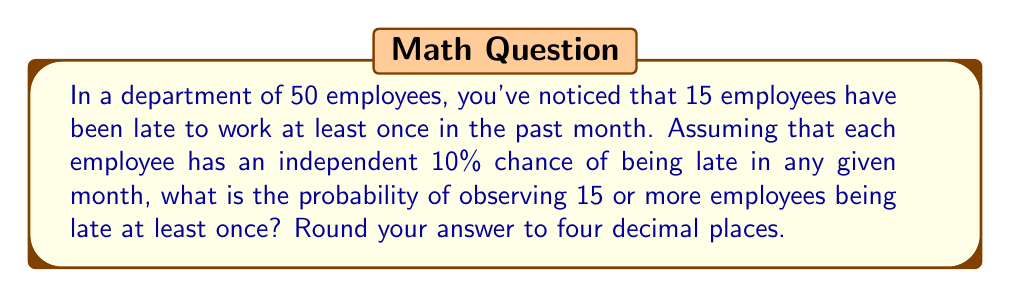Solve this math problem. To solve this problem, we can use the binomial distribution and its cumulative probability function. Let's break it down step-by-step:

1) We have a binomial distribution with parameters:
   $n = 50$ (total number of employees)
   $p = 0.10$ (probability of an employee being late)

2) We want to find $P(X \geq 15)$, where $X$ is the number of employees who are late at least once.

3) This is equivalent to $1 - P(X \leq 14)$

4) The cumulative binomial probability function is:

   $$P(X \leq k) = \sum_{i=0}^k \binom{n}{i} p^i (1-p)^{n-i}$$

5) In our case:

   $$P(X \leq 14) = \sum_{i=0}^{14} \binom{50}{i} (0.10)^i (0.90)^{50-i}$$

6) This calculation is complex to do by hand, so we would typically use statistical software or a calculator with a binomial cumulative distribution function.

7) Using such a tool, we find that $P(X \leq 14) \approx 0.0178$

8) Therefore, $P(X \geq 15) = 1 - P(X \leq 14) \approx 1 - 0.0178 = 0.9822$

9) Rounding to four decimal places, we get 0.9822.

This result suggests that the probability of observing 15 or more employees being late at least once in a month is very high, given the assumed 10% individual probability. This could indicate that either the assumed probability is too high, or there might be other factors influencing employee tardiness.
Answer: 0.9822 